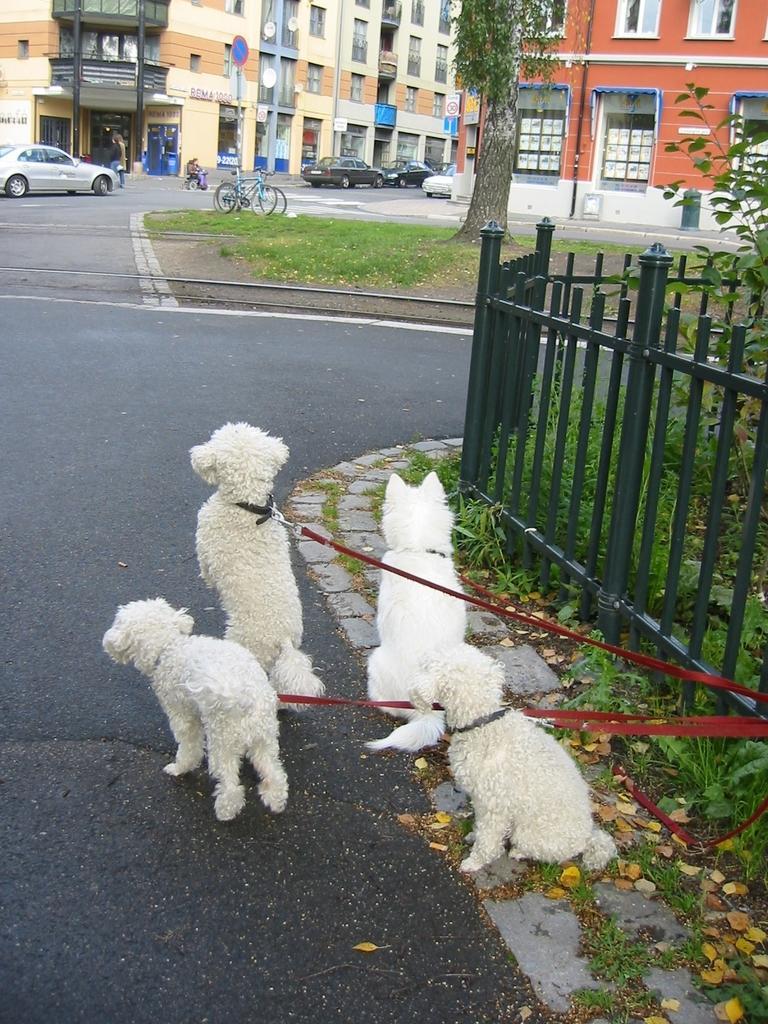How would you summarize this image in a sentence or two? In this image I can see few white colour dogs, red colour belts, grass, a tree, few buildings, few vehicles, few bicycles, few moles, a sign board and number of windows. I can also see few people over there. 